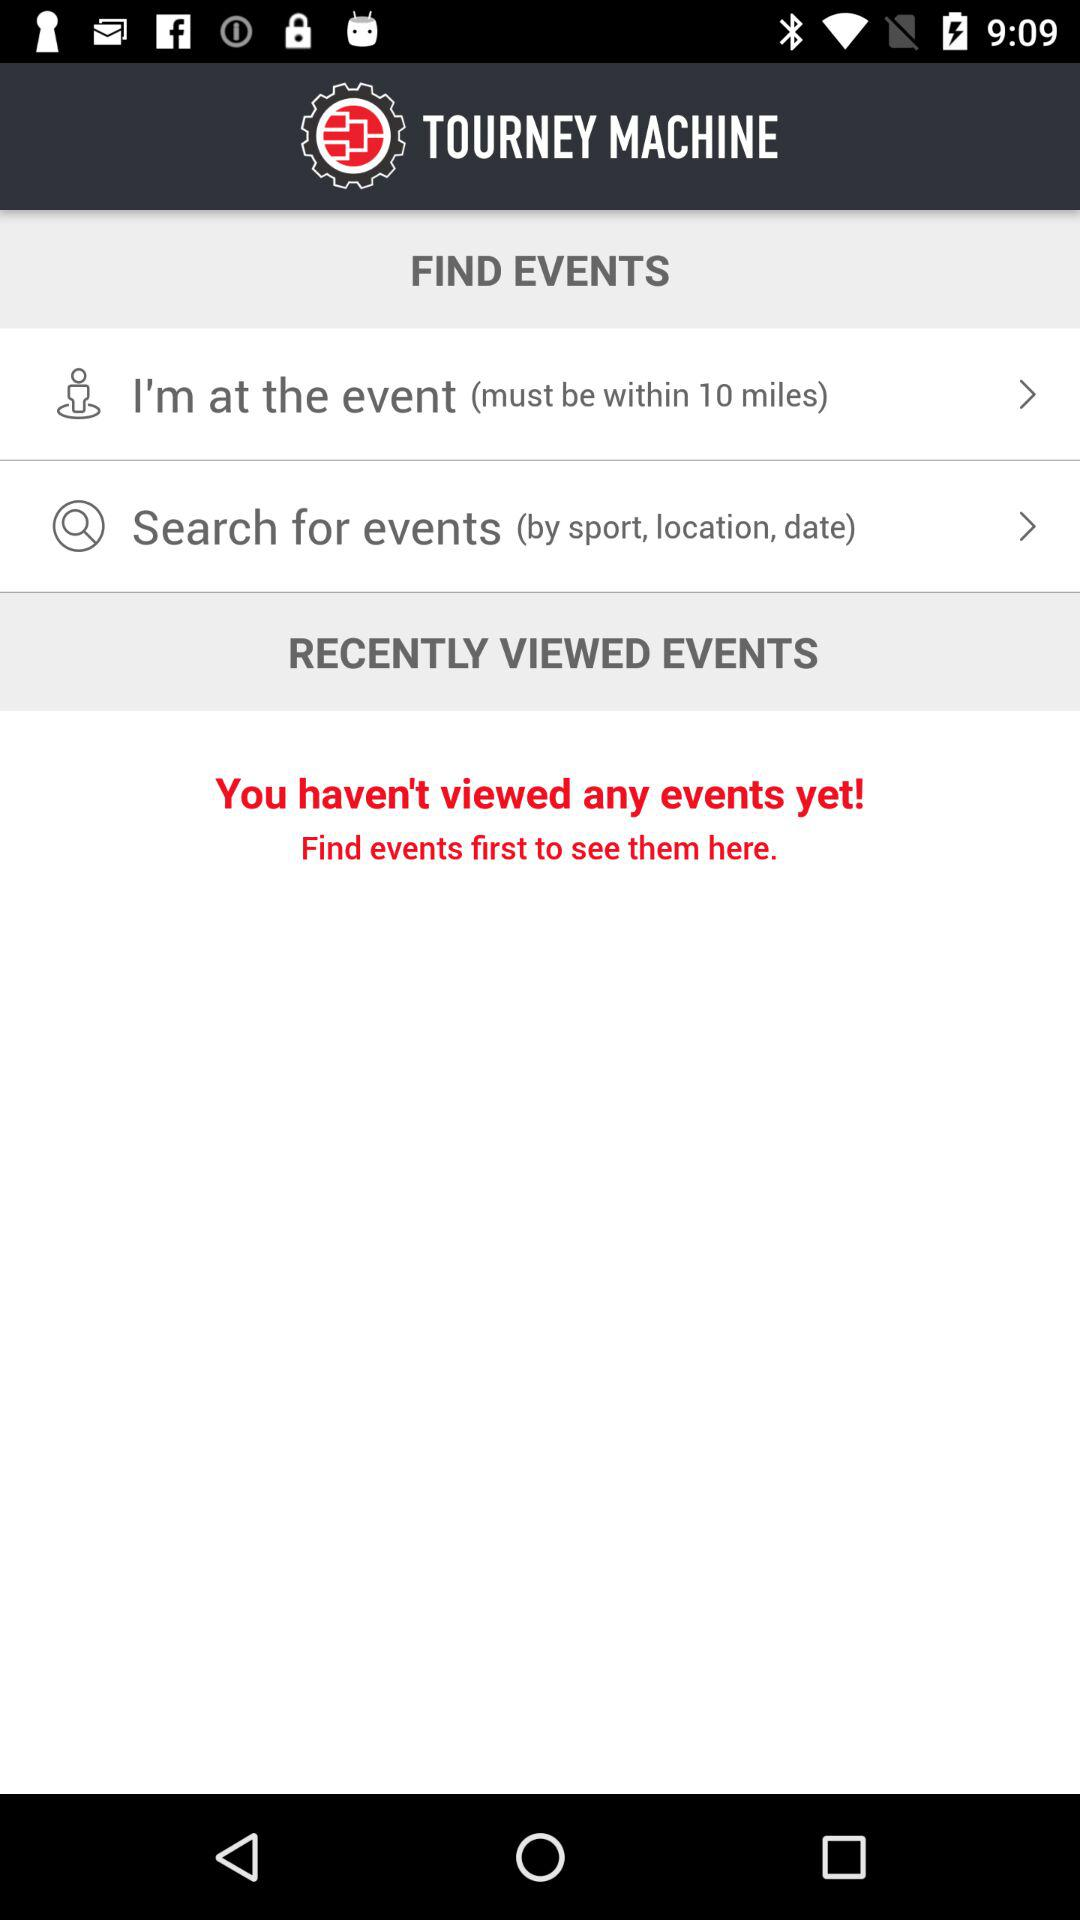How many events have I viewed?
Answer the question using a single word or phrase. 0 